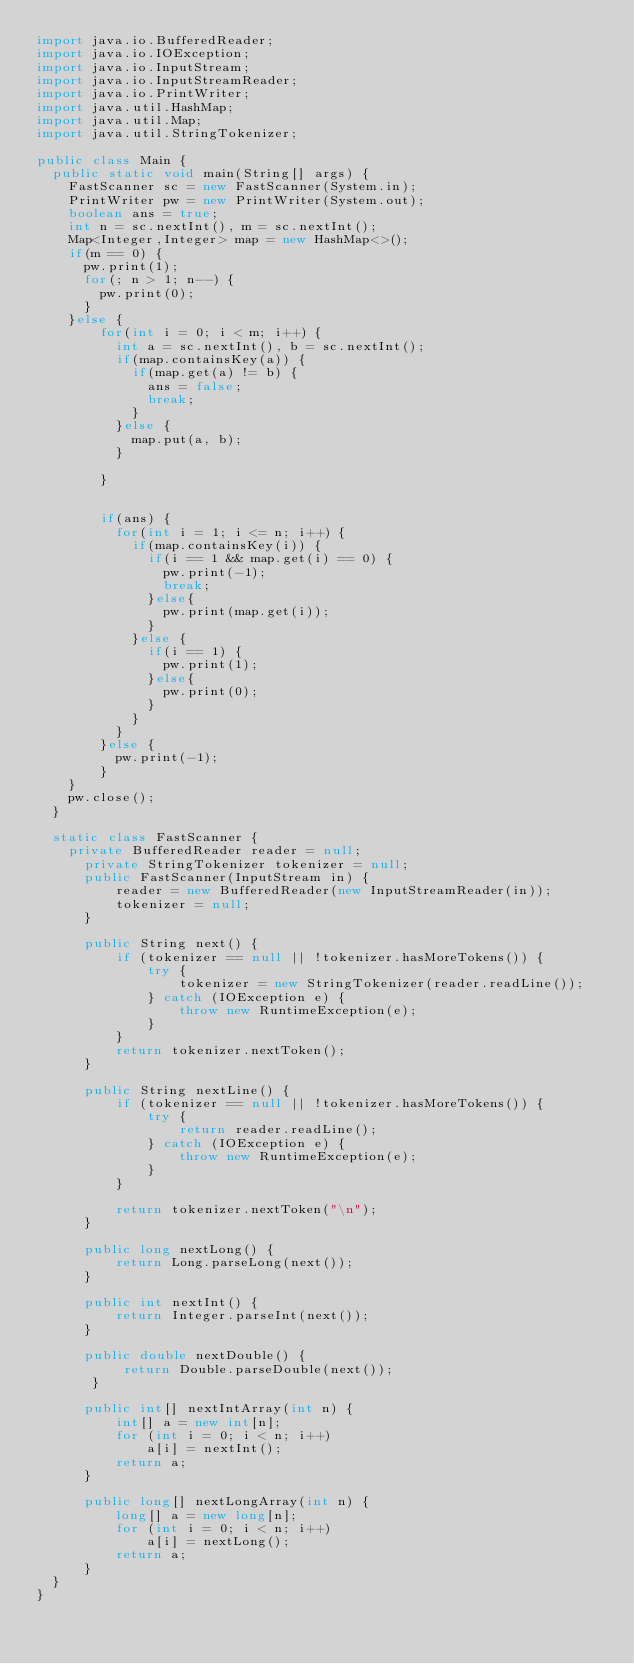<code> <loc_0><loc_0><loc_500><loc_500><_Java_>import java.io.BufferedReader;
import java.io.IOException;
import java.io.InputStream;
import java.io.InputStreamReader;
import java.io.PrintWriter;
import java.util.HashMap;
import java.util.Map;
import java.util.StringTokenizer;

public class Main {
	public static void main(String[] args) {
		FastScanner sc = new FastScanner(System.in);
		PrintWriter pw = new PrintWriter(System.out);
		boolean ans = true;
		int n = sc.nextInt(), m = sc.nextInt();
		Map<Integer,Integer> map = new HashMap<>();
		if(m == 0) {
			pw.print(1);
			for(; n > 1; n--) {
				pw.print(0);
			}
		}else {
				for(int i = 0; i < m; i++) {
					int a = sc.nextInt(), b = sc.nextInt();
					if(map.containsKey(a)) {
						if(map.get(a) != b) {
							ans = false;
							break;
						}
					}else {
						map.put(a, b);
					}
			
				}
				
				
				if(ans) {
					for(int i = 1; i <= n; i++) {
						if(map.containsKey(i)) {
							if(i == 1 && map.get(i) == 0) {
								pw.print(-1);
								break;
							}else{
								pw.print(map.get(i));
							}
						}else {
							if(i == 1) {
								pw.print(1);
							}else{
								pw.print(0);
							}	
						}
					}
				}else {
					pw.print(-1);
				}
		}
		pw.close();
	}
	
	static class FastScanner {
		private BufferedReader reader = null;
	    private StringTokenizer tokenizer = null;
	    public FastScanner(InputStream in) {
	        reader = new BufferedReader(new InputStreamReader(in));
	        tokenizer = null;
	    }

	    public String next() {
	        if (tokenizer == null || !tokenizer.hasMoreTokens()) {
	            try {
	                tokenizer = new StringTokenizer(reader.readLine());
	            } catch (IOException e) {
	                throw new RuntimeException(e);
	            }
	        }
	        return tokenizer.nextToken();
	    }

	    public String nextLine() {
	        if (tokenizer == null || !tokenizer.hasMoreTokens()) {
	            try {
	                return reader.readLine();
	            } catch (IOException e) {
	                throw new RuntimeException(e);
	            }
	        }

	        return tokenizer.nextToken("\n");
	    }

	    public long nextLong() {
	        return Long.parseLong(next());
	    }

	    public int nextInt() {
	        return Integer.parseInt(next());
	    }

	    public double nextDouble() {
	         return Double.parseDouble(next());
	     }

	    public int[] nextIntArray(int n) {
	        int[] a = new int[n];
	        for (int i = 0; i < n; i++)
	            a[i] = nextInt();
	        return a;
	    }

	    public long[] nextLongArray(int n) {
	        long[] a = new long[n];
	        for (int i = 0; i < n; i++)
	            a[i] = nextLong();
	        return a;
	    }
	}
}</code> 